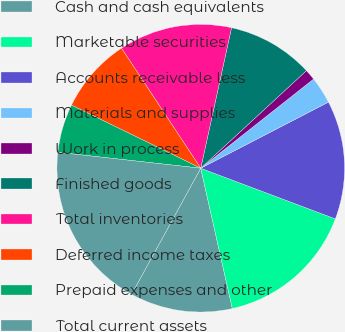Convert chart. <chart><loc_0><loc_0><loc_500><loc_500><pie_chart><fcel>Cash and cash equivalents<fcel>Marketable securities<fcel>Accounts receivable less<fcel>Materials and supplies<fcel>Work in process<fcel>Finished goods<fcel>Total inventories<fcel>Deferred income taxes<fcel>Prepaid expenses and other<fcel>Total current assets<nl><fcel>11.51%<fcel>15.75%<fcel>13.33%<fcel>3.04%<fcel>1.22%<fcel>9.7%<fcel>12.72%<fcel>8.49%<fcel>5.46%<fcel>18.78%<nl></chart> 